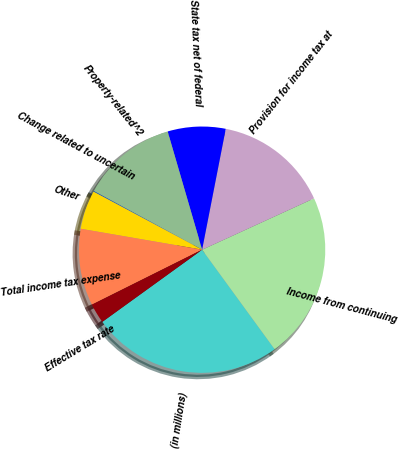<chart> <loc_0><loc_0><loc_500><loc_500><pie_chart><fcel>(in millions)<fcel>Income from continuing<fcel>Provision for income tax at<fcel>State tax net of federal<fcel>Property-related^2<fcel>Change related to uncertain<fcel>Other<fcel>Total income tax expense<fcel>Effective tax rate<nl><fcel>25.06%<fcel>21.82%<fcel>15.08%<fcel>7.59%<fcel>12.58%<fcel>0.1%<fcel>5.09%<fcel>10.08%<fcel>2.6%<nl></chart> 